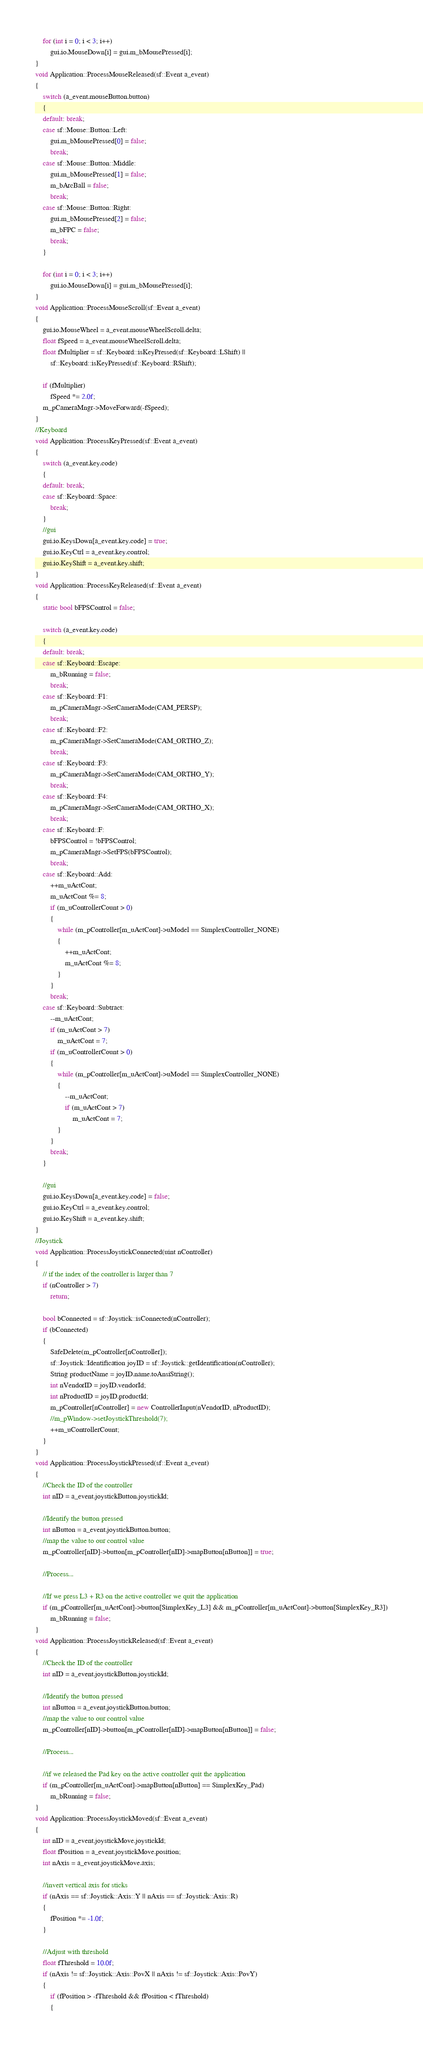Convert code to text. <code><loc_0><loc_0><loc_500><loc_500><_C++_>	for (int i = 0; i < 3; i++)
		gui.io.MouseDown[i] = gui.m_bMousePressed[i];
}
void Application::ProcessMouseReleased(sf::Event a_event)
{
	switch (a_event.mouseButton.button)
	{
	default: break;
	case sf::Mouse::Button::Left:
		gui.m_bMousePressed[0] = false;
		break;
	case sf::Mouse::Button::Middle:
		gui.m_bMousePressed[1] = false;
		m_bArcBall = false;
		break;
	case sf::Mouse::Button::Right:
		gui.m_bMousePressed[2] = false;
		m_bFPC = false;
		break;
	}

	for (int i = 0; i < 3; i++)
		gui.io.MouseDown[i] = gui.m_bMousePressed[i];
}
void Application::ProcessMouseScroll(sf::Event a_event)
{
	gui.io.MouseWheel = a_event.mouseWheelScroll.delta;
	float fSpeed = a_event.mouseWheelScroll.delta;
	float fMultiplier = sf::Keyboard::isKeyPressed(sf::Keyboard::LShift) ||
		sf::Keyboard::isKeyPressed(sf::Keyboard::RShift);

	if (fMultiplier)
		fSpeed *= 2.0f;
	m_pCameraMngr->MoveForward(-fSpeed);
}
//Keyboard
void Application::ProcessKeyPressed(sf::Event a_event)
{
	switch (a_event.key.code)
	{
	default: break;
	case sf::Keyboard::Space:
		break;
	}
	//gui
	gui.io.KeysDown[a_event.key.code] = true;
	gui.io.KeyCtrl = a_event.key.control;
	gui.io.KeyShift = a_event.key.shift;
}
void Application::ProcessKeyReleased(sf::Event a_event)
{
	static bool bFPSControl = false;

	switch (a_event.key.code)
	{
	default: break;
	case sf::Keyboard::Escape:
		m_bRunning = false;
		break;
	case sf::Keyboard::F1:
		m_pCameraMngr->SetCameraMode(CAM_PERSP);
		break;
	case sf::Keyboard::F2:
		m_pCameraMngr->SetCameraMode(CAM_ORTHO_Z);
		break;
	case sf::Keyboard::F3:
		m_pCameraMngr->SetCameraMode(CAM_ORTHO_Y);
		break;
	case sf::Keyboard::F4:
		m_pCameraMngr->SetCameraMode(CAM_ORTHO_X);
		break;
	case sf::Keyboard::F:
		bFPSControl = !bFPSControl;
		m_pCameraMngr->SetFPS(bFPSControl);
		break;
	case sf::Keyboard::Add:
		++m_uActCont;
		m_uActCont %= 8;
		if (m_uControllerCount > 0)
		{
			while (m_pController[m_uActCont]->uModel == SimplexController_NONE)
			{
				++m_uActCont;
				m_uActCont %= 8;
			}
		}
		break;
	case sf::Keyboard::Subtract:
		--m_uActCont;
		if (m_uActCont > 7)
			m_uActCont = 7;
		if (m_uControllerCount > 0)
		{
			while (m_pController[m_uActCont]->uModel == SimplexController_NONE)
			{
				--m_uActCont;
				if (m_uActCont > 7)
					m_uActCont = 7;
			}
		}
		break;
	}

	//gui
	gui.io.KeysDown[a_event.key.code] = false;
	gui.io.KeyCtrl = a_event.key.control;
	gui.io.KeyShift = a_event.key.shift;
}
//Joystick
void Application::ProcessJoystickConnected(uint nController)
{
	// if the index of the controller is larger than 7
	if (nController > 7)
		return;

	bool bConnected = sf::Joystick::isConnected(nController);
	if (bConnected)
	{
		SafeDelete(m_pController[nController]);
		sf::Joystick::Identification joyID = sf::Joystick::getIdentification(nController);
		String productName = joyID.name.toAnsiString();
		int nVendorID = joyID.vendorId;
		int nProductID = joyID.productId;
		m_pController[nController] = new ControllerInput(nVendorID, nProductID);
		//m_pWindow->setJoystickThreshold(7);
		++m_uControllerCount;
	}
}
void Application::ProcessJoystickPressed(sf::Event a_event)
{
	//Check the ID of the controller
	int nID = a_event.joystickButton.joystickId;

	//Identify the button pressed
	int nButton = a_event.joystickButton.button;
	//map the value to our control value
	m_pController[nID]->button[m_pController[nID]->mapButton[nButton]] = true;

	//Process...

	//If we press L3 + R3 on the active controller we quit the application
	if (m_pController[m_uActCont]->button[SimplexKey_L3] && m_pController[m_uActCont]->button[SimplexKey_R3])
		m_bRunning = false;
}
void Application::ProcessJoystickReleased(sf::Event a_event)
{
	//Check the ID of the controller
	int nID = a_event.joystickButton.joystickId;

	//Identify the button pressed
	int nButton = a_event.joystickButton.button;
	//map the value to our control value
	m_pController[nID]->button[m_pController[nID]->mapButton[nButton]] = false;

	//Process...

	//if we released the Pad key on the active controller quit the application
	if (m_pController[m_uActCont]->mapButton[nButton] == SimplexKey_Pad)
		m_bRunning = false;
}
void Application::ProcessJoystickMoved(sf::Event a_event)
{
	int nID = a_event.joystickMove.joystickId;
	float fPosition = a_event.joystickMove.position;
	int nAxis = a_event.joystickMove.axis;

	//invert vertical axis for sticks
	if (nAxis == sf::Joystick::Axis::Y || nAxis == sf::Joystick::Axis::R)
	{
		fPosition *= -1.0f;
	}

	//Adjust with threshold
	float fThreshold = 10.0f;
	if (nAxis != sf::Joystick::Axis::PovX || nAxis != sf::Joystick::Axis::PovY)
	{
		if (fPosition > -fThreshold && fPosition < fThreshold)
		{</code> 